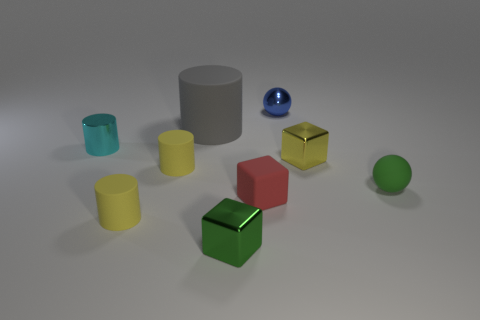Subtract all yellow cylinders. How many were subtracted if there are1yellow cylinders left? 1 Subtract all green cubes. How many cubes are left? 2 Subtract all large gray matte cylinders. How many cylinders are left? 3 Subtract all cubes. How many objects are left? 6 Subtract 1 cubes. How many cubes are left? 2 Subtract all blue blocks. Subtract all cyan spheres. How many blocks are left? 3 Subtract all brown cubes. How many red balls are left? 0 Subtract all small yellow metallic things. Subtract all tiny green blocks. How many objects are left? 7 Add 5 blue metallic balls. How many blue metallic balls are left? 6 Add 8 big brown matte objects. How many big brown matte objects exist? 8 